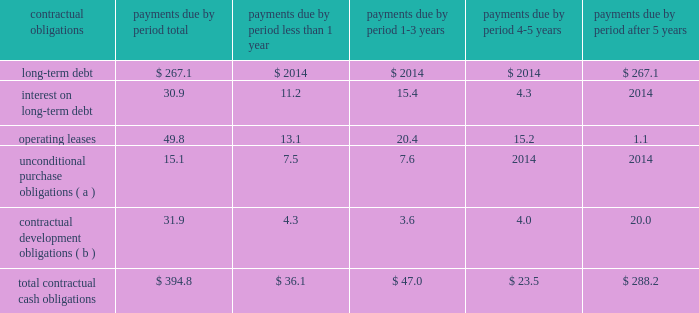) increased net cash flows from receivables from improved days sales outstanding offsetting increased sales levels ; partially offset by reduced cash flows from increases in inventories to build new product lines and support increased sales levels .
Cash provided by operating activities in 2003 decreased $ 8.4 million from 2002 due primarily to : ) reduced cash inflows from accounts receivable securitization ; and ) reduced cash inflows from increases in inventories partially offset by : ) higher earnings in 2003 before non-cash charges and credits ; ) decreased net cash outflows from accounts and other receivables ; and ) decreased net cash outflows from accounts payable and accrued expenses .
Net cash used in investing activities in 2004 consisted primarily of the acquisition of pvt and the purchase of ev3 2019s technology of $ 137.7 million , and capital expenditures of $ 42.5 million .
Net cash used in investing activities in 2003 consisted primarily of the acquisition of jomed , whitland and embol-x , inc .
Of $ 33.2 million , and capital expenditures of $ 37.9 million .
Net cash used in financing activities in 2004 consisted primarily of purchases of treasury stock of $ 59.1 million , partially offset by proceeds from stock plans of $ 30.5 million and net proceeds from issuance of long-term debt of $ 7.1 million .
Cash used in financing activities in 2003 consisted primarily of purchases of treasury stock of $ 49.4 million and net payments on debt of $ 4.0 million , partially offset by proceeds from stock plans of $ 36.6 million .
A summary of all of the company 2019s contractual obligations and commercial commitments as of december 31 , 2004 were as follows ( in millions ) : .
Less than after contractual obligations total 1 year 1-3 years 4-5 years 5 years long-term debt *************************** $ 267.1 $ 2014 $ 2014 $ 2014 $ 267.1 interest on long-term debt ****************** 30.9 11.2 15.4 4.3 2014 operating leases*************************** 49.8 13.1 20.4 15.2 1.1 unconditional purchase obligations ( a ) ********* 15.1 7.5 7.6 2014 2014 contractual development obligations ( b ) ******** 31.9 4.3 3.6 4.0 20.0 total contractual cash obligations************* $ 394.8 $ 36.1 $ 47.0 $ 23.5 $ 288.2 ( a ) unconditional purchase obligations consist primarily of minimum purchase commitments of inventory .
( b ) contractual development obligations consist primarily of cash that edwards lifesciences is obligated to pay to unconsolidated affiliates upon their achievement of product development milestones .
Critical accounting policies and estimates the company 2019s results of operations and financial position are determined based upon the application of the company 2019s accounting policies , as discussed in the notes to the consolidated financial statements .
Certain of the company 2019s accounting policies represent a selection among acceptable alternatives under generally accepted .
What percent of total contractual cash obligations is due to operating leases? 
Computations: (49.8 / 394.8)
Answer: 0.12614. 